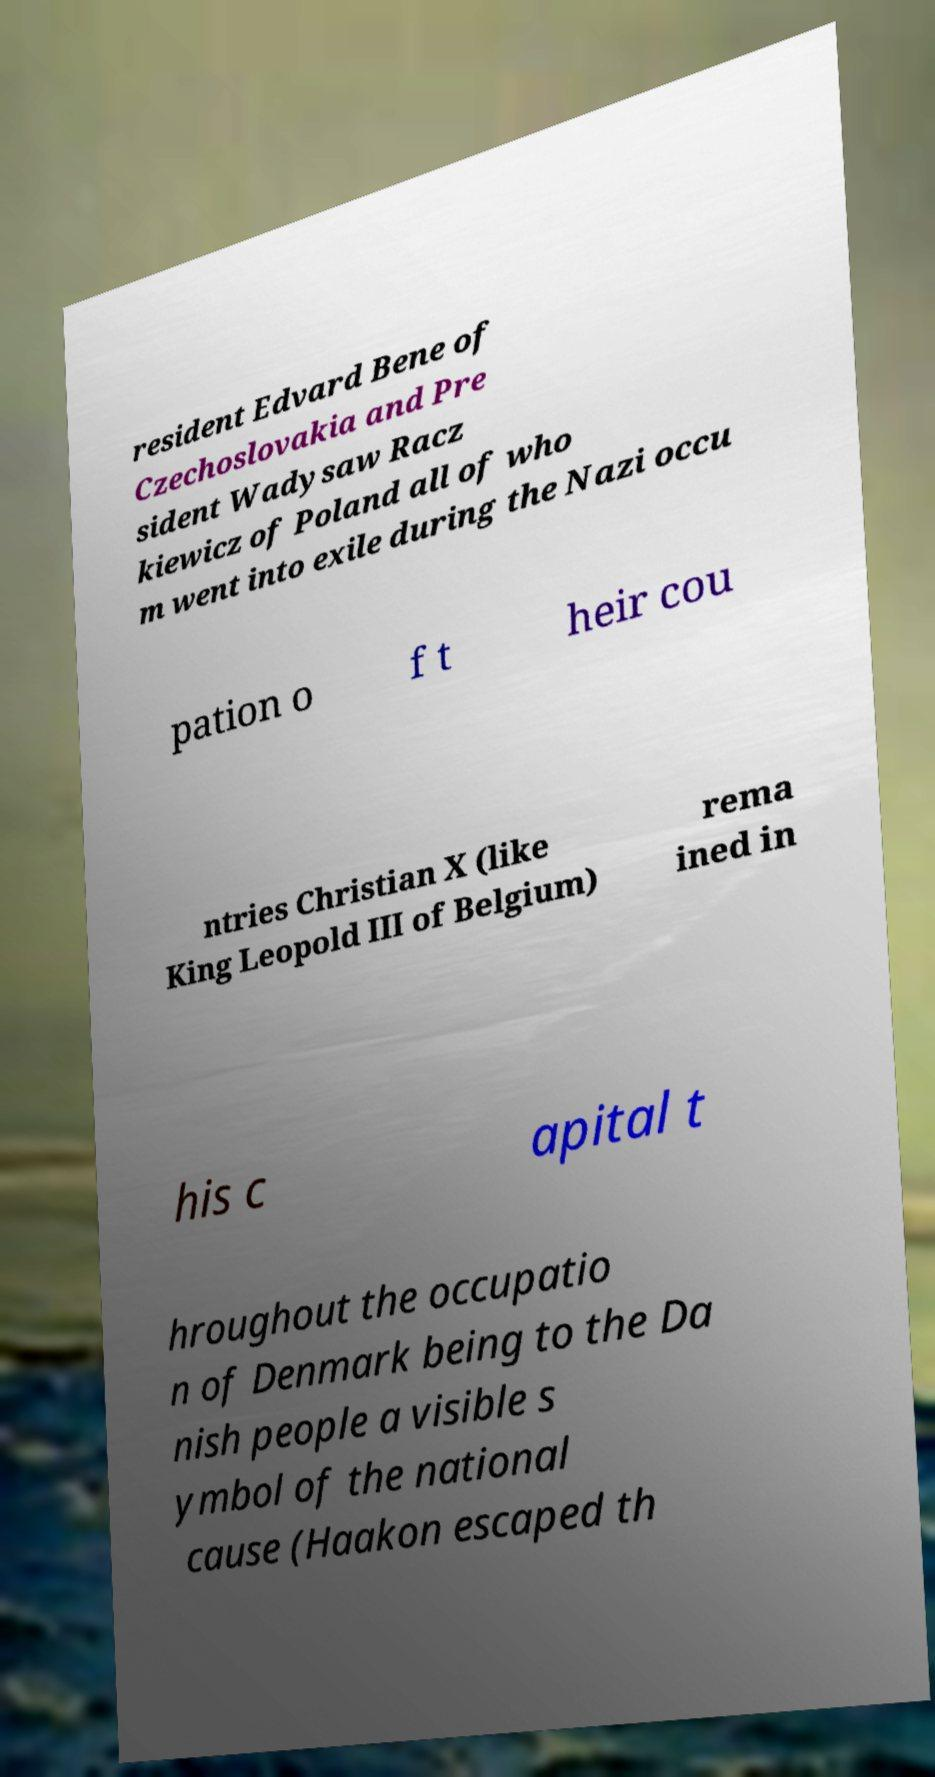Please read and relay the text visible in this image. What does it say? resident Edvard Bene of Czechoslovakia and Pre sident Wadysaw Racz kiewicz of Poland all of who m went into exile during the Nazi occu pation o f t heir cou ntries Christian X (like King Leopold III of Belgium) rema ined in his c apital t hroughout the occupatio n of Denmark being to the Da nish people a visible s ymbol of the national cause (Haakon escaped th 